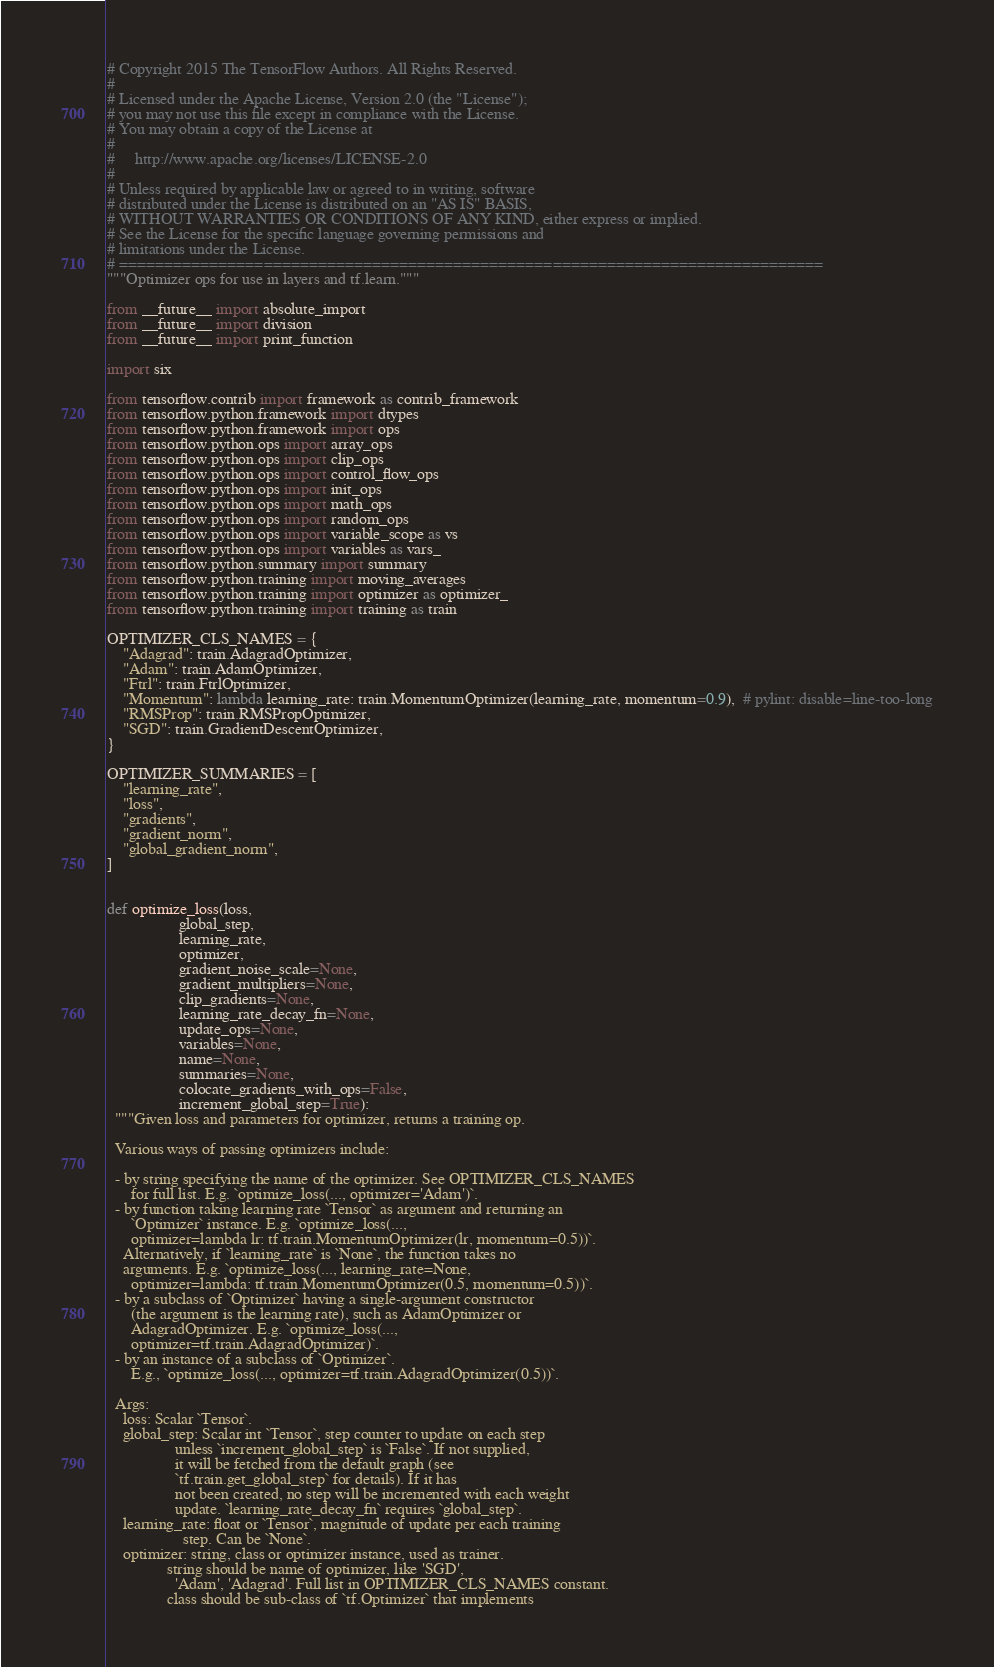<code> <loc_0><loc_0><loc_500><loc_500><_Python_># Copyright 2015 The TensorFlow Authors. All Rights Reserved.
#
# Licensed under the Apache License, Version 2.0 (the "License");
# you may not use this file except in compliance with the License.
# You may obtain a copy of the License at
#
#     http://www.apache.org/licenses/LICENSE-2.0
#
# Unless required by applicable law or agreed to in writing, software
# distributed under the License is distributed on an "AS IS" BASIS,
# WITHOUT WARRANTIES OR CONDITIONS OF ANY KIND, either express or implied.
# See the License for the specific language governing permissions and
# limitations under the License.
# ==============================================================================
"""Optimizer ops for use in layers and tf.learn."""

from __future__ import absolute_import
from __future__ import division
from __future__ import print_function

import six

from tensorflow.contrib import framework as contrib_framework
from tensorflow.python.framework import dtypes
from tensorflow.python.framework import ops
from tensorflow.python.ops import array_ops
from tensorflow.python.ops import clip_ops
from tensorflow.python.ops import control_flow_ops
from tensorflow.python.ops import init_ops
from tensorflow.python.ops import math_ops
from tensorflow.python.ops import random_ops
from tensorflow.python.ops import variable_scope as vs
from tensorflow.python.ops import variables as vars_
from tensorflow.python.summary import summary
from tensorflow.python.training import moving_averages
from tensorflow.python.training import optimizer as optimizer_
from tensorflow.python.training import training as train

OPTIMIZER_CLS_NAMES = {
    "Adagrad": train.AdagradOptimizer,
    "Adam": train.AdamOptimizer,
    "Ftrl": train.FtrlOptimizer,
    "Momentum": lambda learning_rate: train.MomentumOptimizer(learning_rate, momentum=0.9),  # pylint: disable=line-too-long
    "RMSProp": train.RMSPropOptimizer,
    "SGD": train.GradientDescentOptimizer,
}

OPTIMIZER_SUMMARIES = [
    "learning_rate",
    "loss",
    "gradients",
    "gradient_norm",
    "global_gradient_norm",
]


def optimize_loss(loss,
                  global_step,
                  learning_rate,
                  optimizer,
                  gradient_noise_scale=None,
                  gradient_multipliers=None,
                  clip_gradients=None,
                  learning_rate_decay_fn=None,
                  update_ops=None,
                  variables=None,
                  name=None,
                  summaries=None,
                  colocate_gradients_with_ops=False,
                  increment_global_step=True):
  """Given loss and parameters for optimizer, returns a training op.

  Various ways of passing optimizers include:

  - by string specifying the name of the optimizer. See OPTIMIZER_CLS_NAMES
      for full list. E.g. `optimize_loss(..., optimizer='Adam')`.
  - by function taking learning rate `Tensor` as argument and returning an
      `Optimizer` instance. E.g. `optimize_loss(...,
      optimizer=lambda lr: tf.train.MomentumOptimizer(lr, momentum=0.5))`.
    Alternatively, if `learning_rate` is `None`, the function takes no
    arguments. E.g. `optimize_loss(..., learning_rate=None,
      optimizer=lambda: tf.train.MomentumOptimizer(0.5, momentum=0.5))`.
  - by a subclass of `Optimizer` having a single-argument constructor
      (the argument is the learning rate), such as AdamOptimizer or
      AdagradOptimizer. E.g. `optimize_loss(...,
      optimizer=tf.train.AdagradOptimizer)`.
  - by an instance of a subclass of `Optimizer`.
      E.g., `optimize_loss(..., optimizer=tf.train.AdagradOptimizer(0.5))`.

  Args:
    loss: Scalar `Tensor`.
    global_step: Scalar int `Tensor`, step counter to update on each step
                 unless `increment_global_step` is `False`. If not supplied,
                 it will be fetched from the default graph (see
                 `tf.train.get_global_step` for details). If it has
                 not been created, no step will be incremented with each weight
                 update. `learning_rate_decay_fn` requires `global_step`.
    learning_rate: float or `Tensor`, magnitude of update per each training
                   step. Can be `None`.
    optimizer: string, class or optimizer instance, used as trainer.
               string should be name of optimizer, like 'SGD',
                 'Adam', 'Adagrad'. Full list in OPTIMIZER_CLS_NAMES constant.
               class should be sub-class of `tf.Optimizer` that implements</code> 